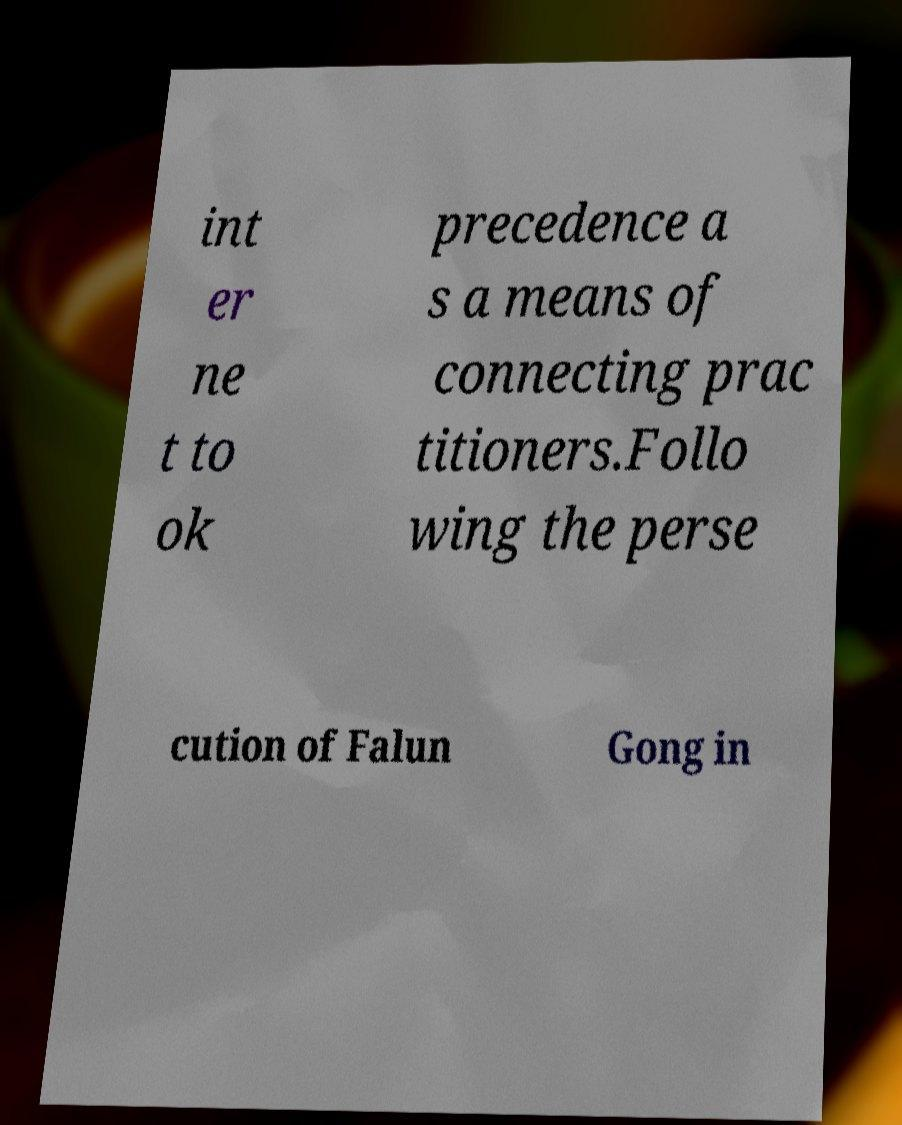Could you assist in decoding the text presented in this image and type it out clearly? int er ne t to ok precedence a s a means of connecting prac titioners.Follo wing the perse cution of Falun Gong in 